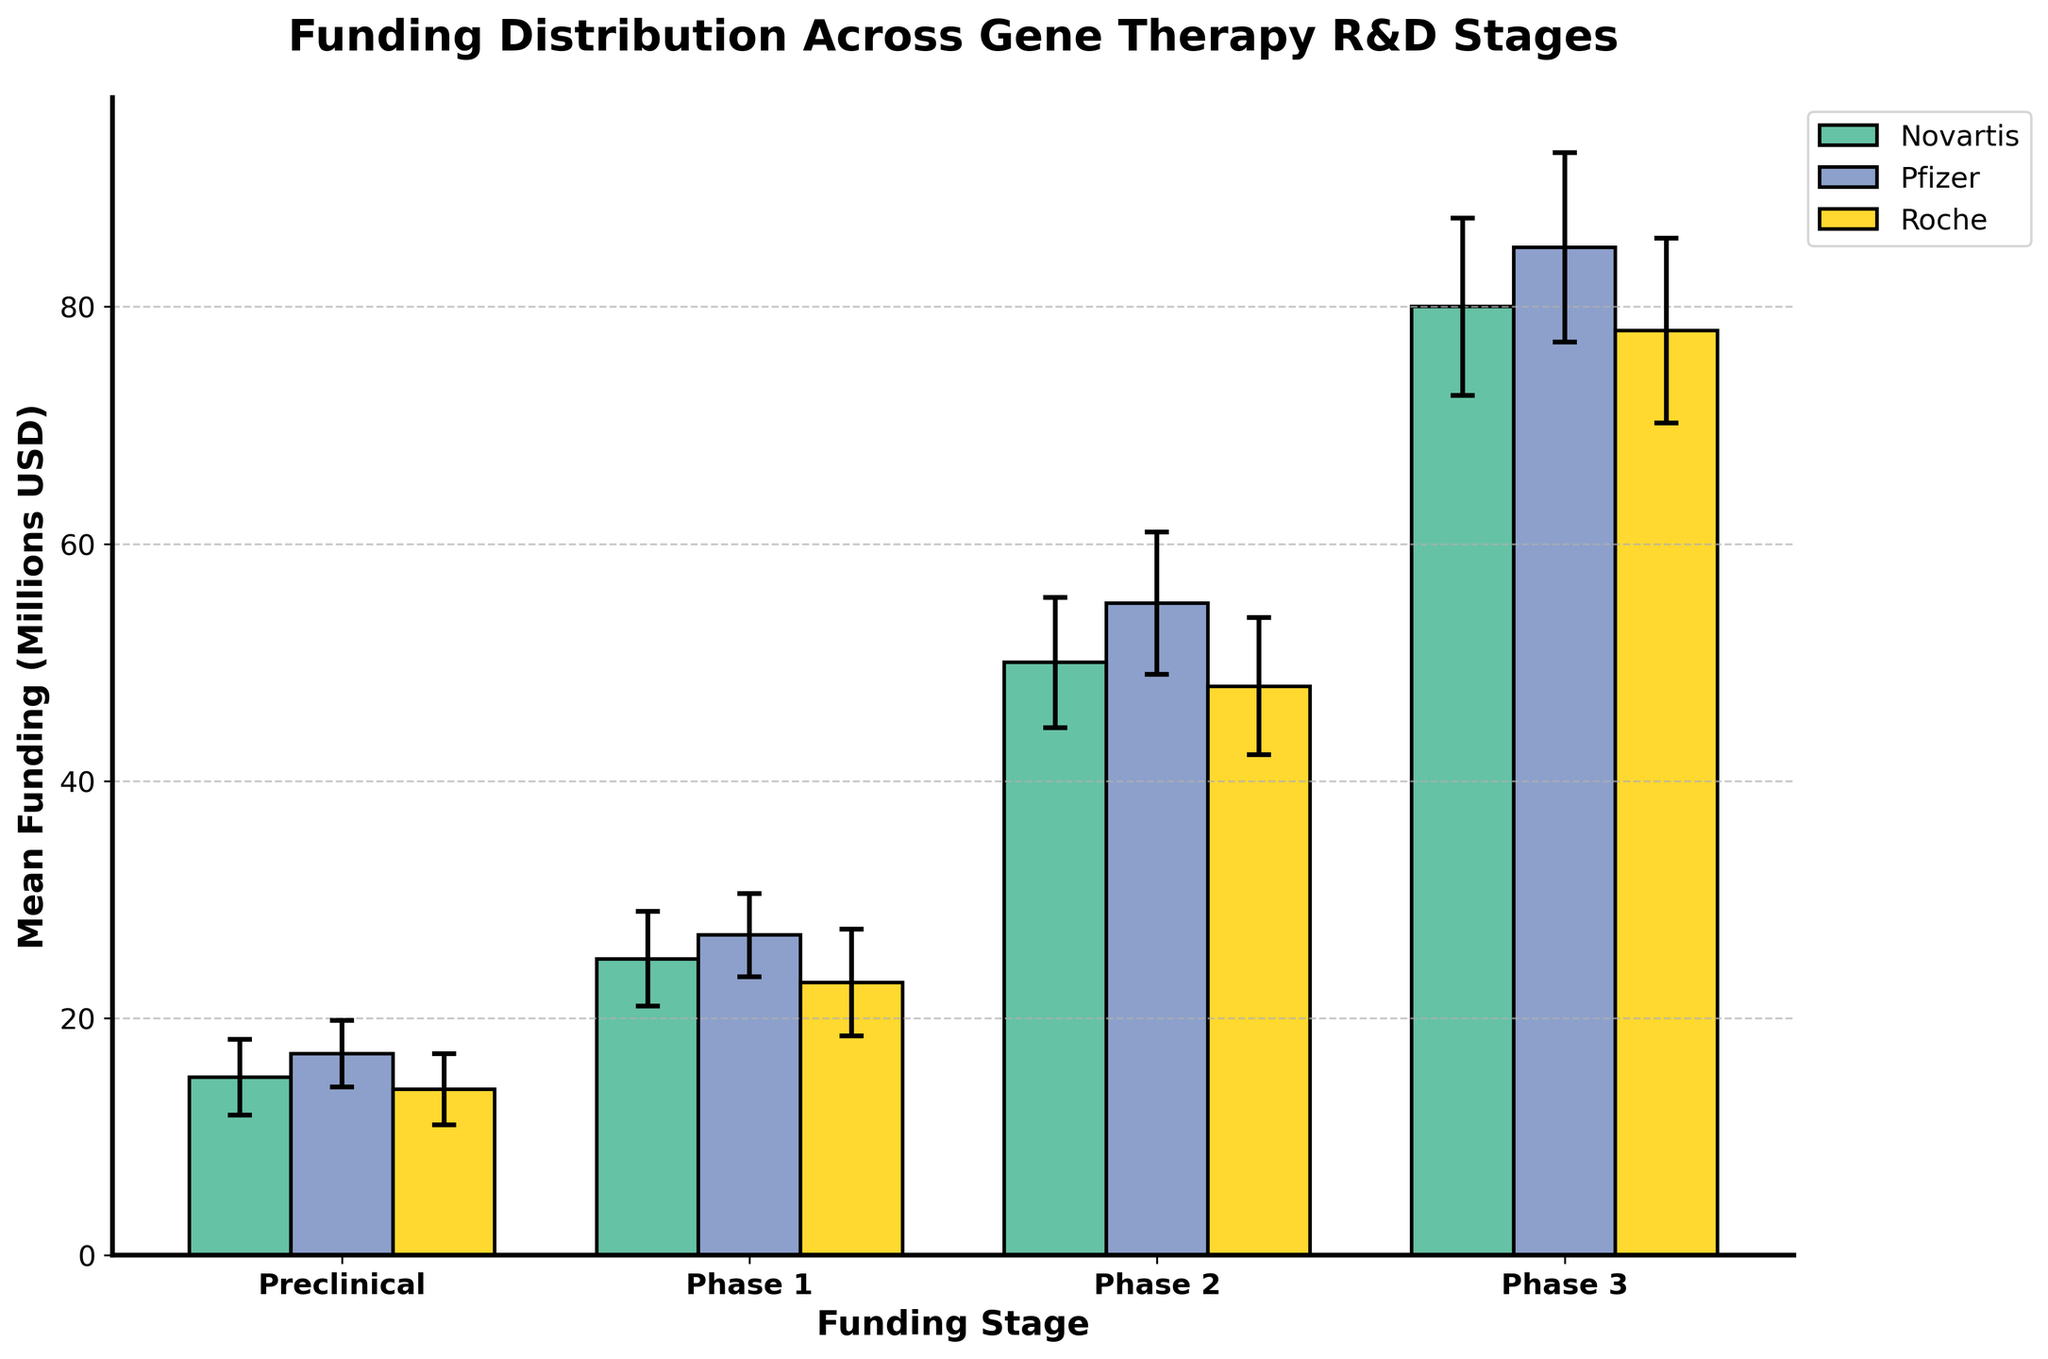What is the title of the chart? The title is displayed at the top of the chart, centered and in bold.
Answer: Funding Distribution Across Gene Therapy R&D Stages What is the average mean funding for Roche in Phase 2 and Phase 3? Display the mean funding for Roche in Phase 2 and Phase 3 bars, then calculate the average: (48 + 78) / 2 = 126 / 2.
Answer: 63 Which company has the highest mean funding in Phase 3? Look at the top of the bars representing Phase 3 and identify the company. Pfizer's bar is the highest in Phase 3.
Answer: Pfizer How much higher is Novartis' mean funding in Phase 3 compared to Phase 1? Identify and subtract Novartis' mean funding values in Phase 1 and Phase 3: 80 - 25.
Answer: 55 What are the companies represented in the chart? Look for the legend on the chart, which lists the companies by name and color.
Answer: Novartis, Pfizer, Roche Which funding stage has the lowest standard deviation for Pfizer? Examine the error bars for Pfizer across all stages; the shortest error bar indicates the lowest standard deviation, which is in Preclinical stage.
Answer: Preclinical How does the mean funding in Preclinical stage for Novartis compare to Roche? Compare the heights of the respective bars in the Preclinical stage; Novartis is at 15 and Roche is at 14.
Answer: Novartis has higher mean funding by 1 million USD What is the range of mean funding for Novartis across all stages? Find the maximum and minimum mean funding for Novartis and calculate the range: max(80) - min(15).
Answer: 65 Which stage shows the highest variability in funding for Pfizer? Look for the longest error bar for Pfizer, which represents the highest standard deviation; it is in Phase 3.
Answer: Phase 3 